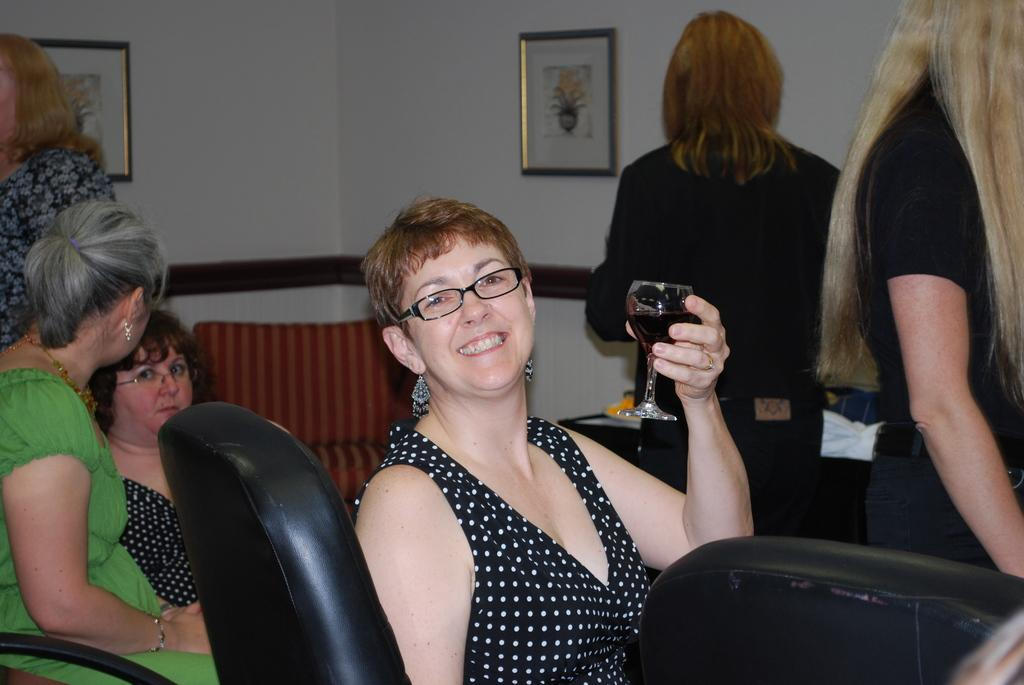What is the woman in the image doing? The woman is sitting in the image and holding a glass. What is the woman's facial expression? The woman is smiling. Are there any other people in the image? Yes, there are two women sitting in the background and three women standing in the background. What can be seen on the wall in the background? There is a frame attached to a wall in the background. How many flocks of underwear can be seen in the image? There are no flocks of underwear present in the image. What type of girls are depicted in the image? The image does not depict any girls; it features women. 